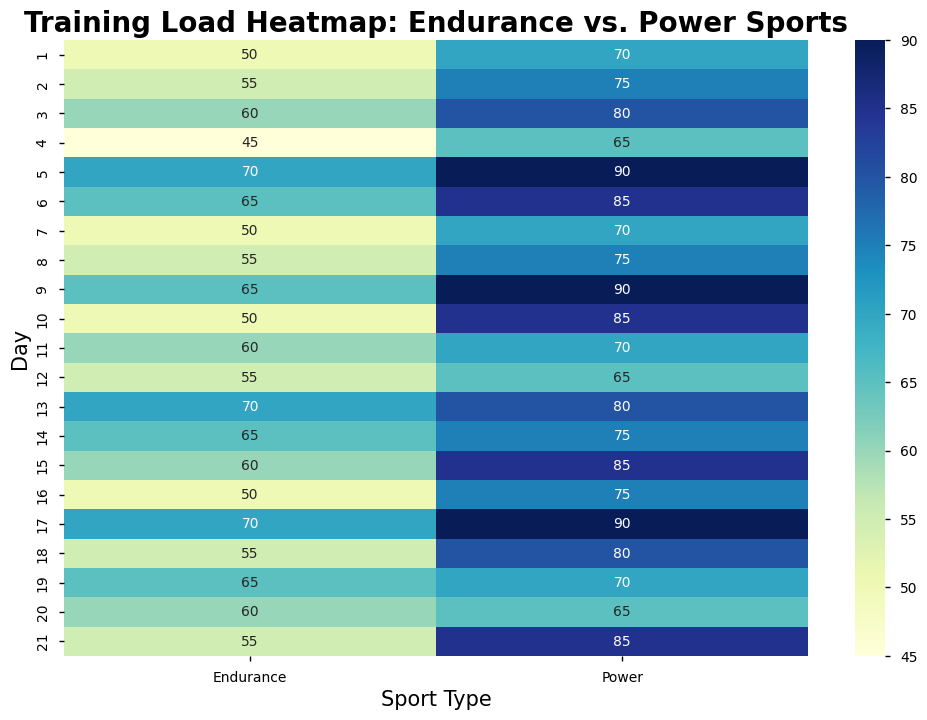Which sport has the highest training load on day 5? Look at the heatmap for day 5 to find the sport with the highest value. Endurance has a training load of 70, and Power has a training load of 90. Thus, Power has the highest training load on day 5.
Answer: Power What is the average training load for Endurance sport over the first week? Sum the training loads for Endurance sport from day 1 to day 7: (50 + 55 + 60 + 45 + 70 + 65 + 50) = 395. There are 7 days, so divide the total by 7. 395/7 ≈ 56.4
Answer: 56.4 On which day do both sports have the same training load? Compare the training loads for each day to find when they match. On day 20, both Endurance and Power have the same training load of 65.
Answer: Day 20 Which sport shows more variability in training load over the three weeks? By visually comparing the heatmap, Power sport exhibits a wider range of values (from 65 to 90) and more color variation (darker blue to lighter blue), indicating more variability.
Answer: Power What's the difference in training load between Endurance and Power sports on day 17? Look at day 17: Endurance has a training load of 70, and Power has a training load of 90. Subtract the smaller value from the larger one: 90 - 70 = 20.
Answer: 20 What is the median training load for Power sport over the first week? List the training loads for Power sport from day 1 to day 7 in ascending order: 65, 70, 70, 75, 80, 85, 90. The median is the middle value, which is 75.
Answer: 75 On which day does Endurance sport have the highest training load? Locate the highest value for Endurance in the heatmap. The highest training load for Endurance is 70, and it occurs on days 5, 13, and 17.
Answer: Days 5, 13, 17 Is there a day when the training load is decreasing for both sports compared to the previous day? Scan through each day and compare values for both sports to the previous day. On day 4 compared to day 3, training load decreases for Endurance (60 to 45) and Power (80 to 65).
Answer: Day 4 Which sport has a higher average training load in the second week (days 8-14)? Calculate the average training load for Endurance from days 8-14: (55 + 65 + 50 + 60 + 55 + 70 + 65) / 7 = 59.43. For Power: (75 + 90 + 85 + 70 + 65 + 80 + 75) / 7 = 77.14. Power’s average is higher.
Answer: Power What pattern can you observe in the training load for Power sport over the weeks? Observe the heatmap’s color changes for Power sport. Training loads show a pattern of alternating high and moderate values, indicating a cycle of increased load followed by a slight decrease, then an increase again.
Answer: Repeating cycles 